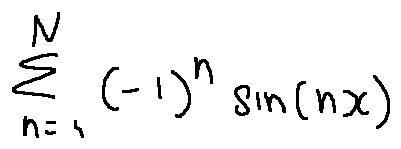Convert formula to latex. <formula><loc_0><loc_0><loc_500><loc_500>\sum \lim i t s _ { n = 1 } ^ { N } ( - 1 ) ^ { n } \sin ( n x )</formula> 